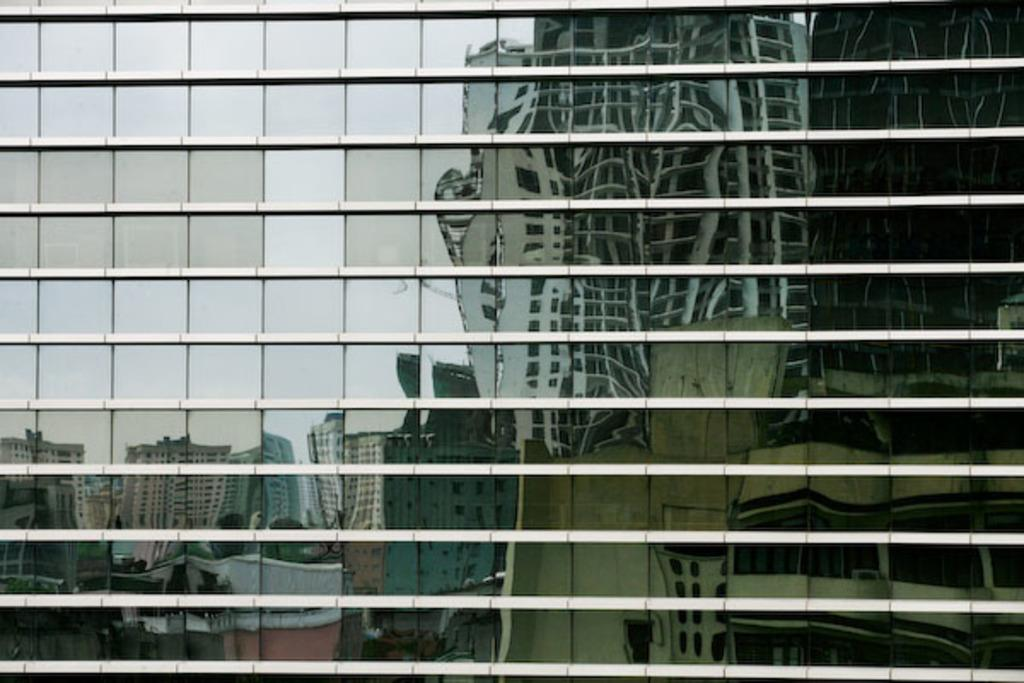What type of structure is present in the image? There is a building in the image. What feature can be observed on the building's exterior? The building has glass windows or surfaces. What can be seen on the glass surfaces of the building? The reflection of other buildings is visible on the building's glass surfaces. How many kittens are playing with the trucks on the glass surfaces of the building? There are no kittens or trucks present on the glass surfaces of the building in the image. 